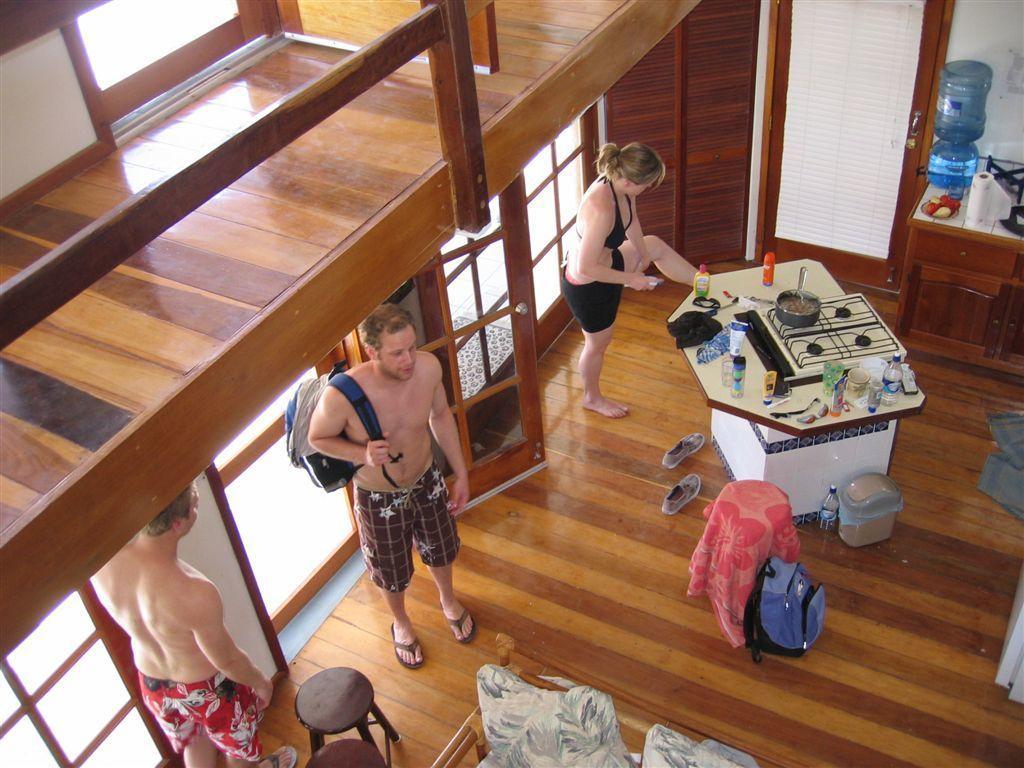Please provide a concise description of this image. These three persons are standing and this person wear bag. We can see bottles,bowl,spoon and things on the table and we can see water bottle, fruits,tissue on the furniture. We can see bag,bottle,shoes,tables on the floor. On the background we can see glass door. We can see pillows. 